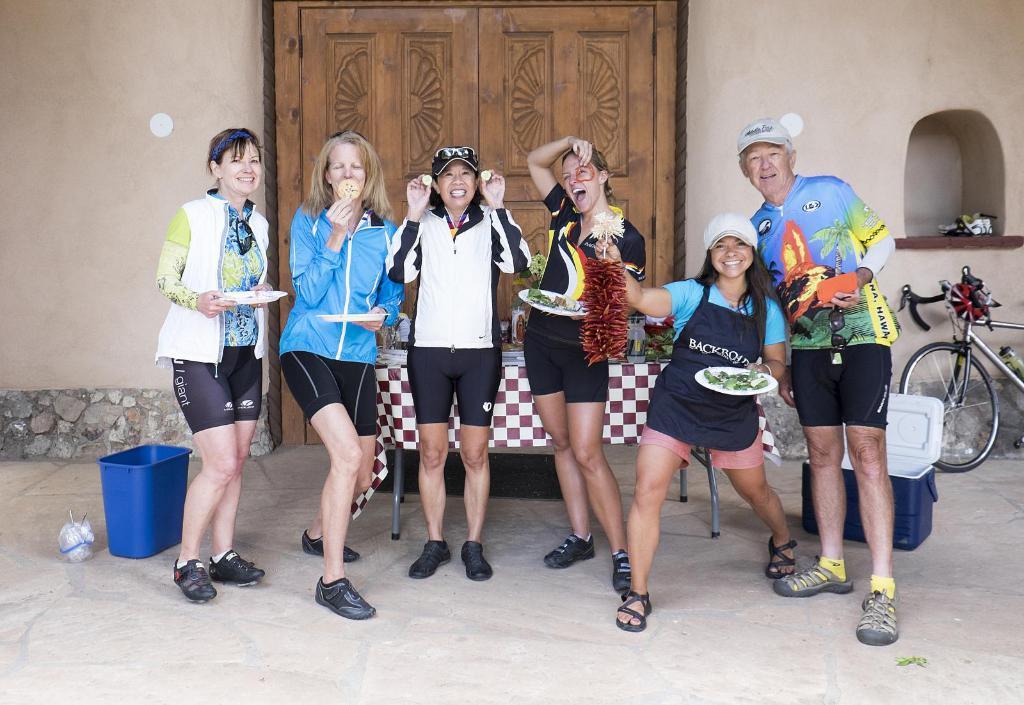Could you give a brief overview of what you see in this image? In this image I can see number of persons are standing on the ground and I can see few of them are holding plates in their hands. In the background I can see a table with few objects on it, a blue colored bucket, a blue and white colored plastic box, a bicycle, the wall and the brown colored door. 